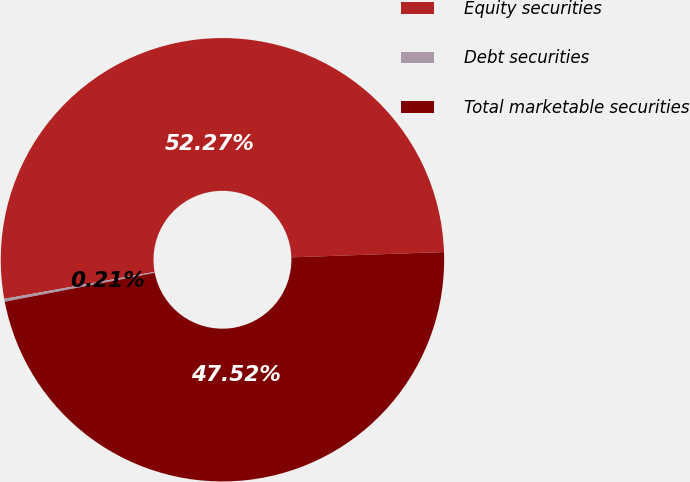Convert chart to OTSL. <chart><loc_0><loc_0><loc_500><loc_500><pie_chart><fcel>Equity securities<fcel>Debt securities<fcel>Total marketable securities<nl><fcel>52.27%<fcel>0.21%<fcel>47.52%<nl></chart> 